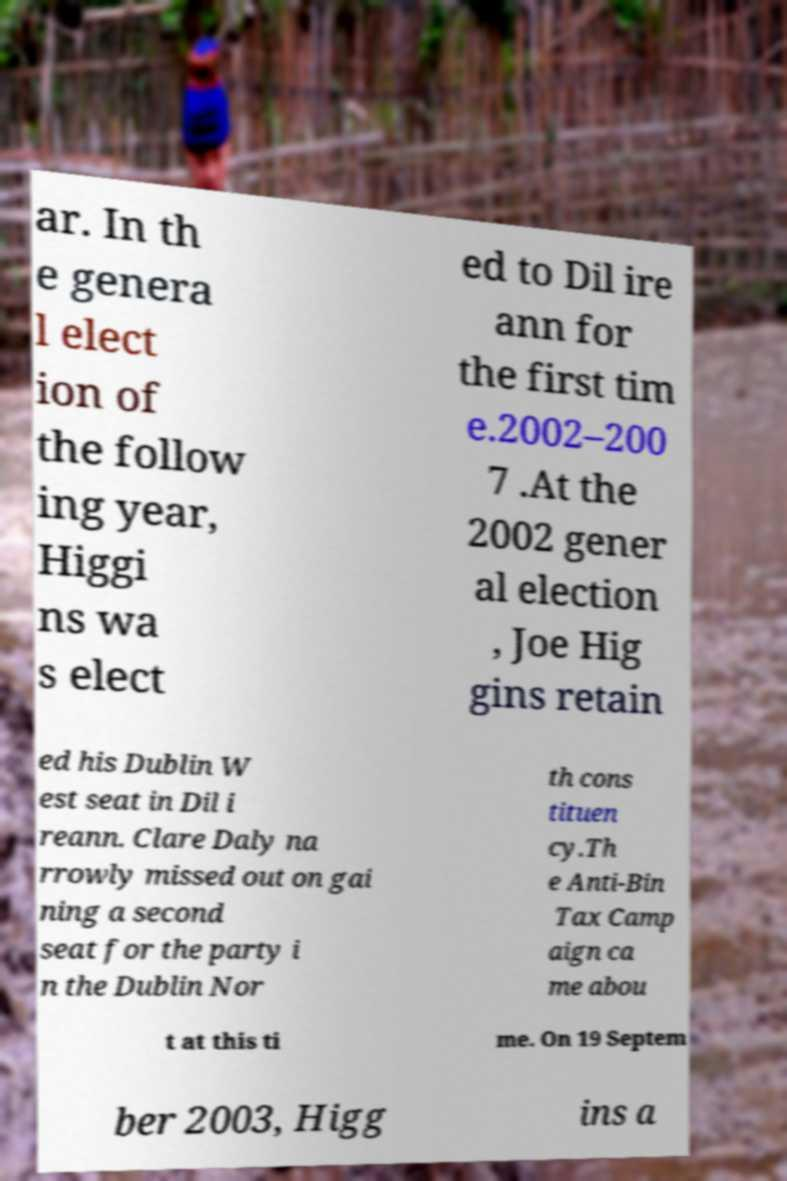There's text embedded in this image that I need extracted. Can you transcribe it verbatim? ar. In th e genera l elect ion of the follow ing year, Higgi ns wa s elect ed to Dil ire ann for the first tim e.2002–200 7 .At the 2002 gener al election , Joe Hig gins retain ed his Dublin W est seat in Dil i reann. Clare Daly na rrowly missed out on gai ning a second seat for the party i n the Dublin Nor th cons tituen cy.Th e Anti-Bin Tax Camp aign ca me abou t at this ti me. On 19 Septem ber 2003, Higg ins a 